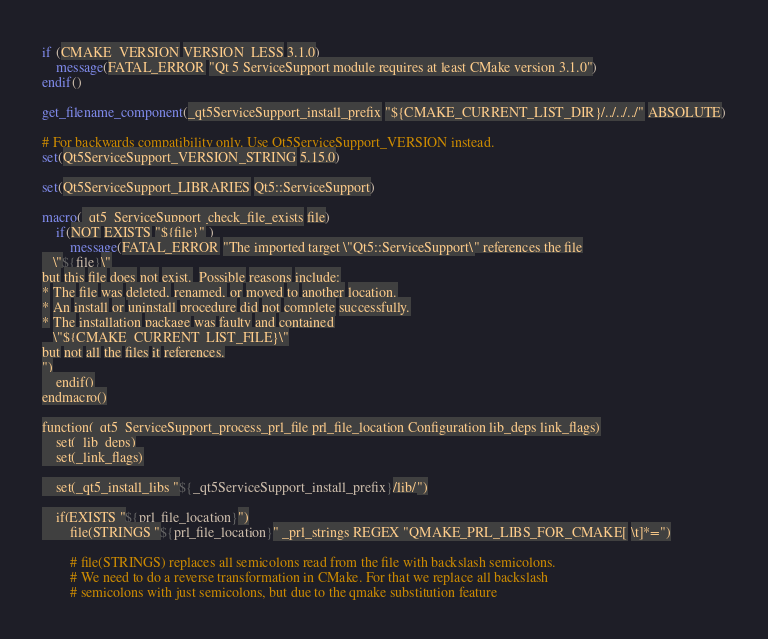Convert code to text. <code><loc_0><loc_0><loc_500><loc_500><_CMake_>if (CMAKE_VERSION VERSION_LESS 3.1.0)
    message(FATAL_ERROR "Qt 5 ServiceSupport module requires at least CMake version 3.1.0")
endif()

get_filename_component(_qt5ServiceSupport_install_prefix "${CMAKE_CURRENT_LIST_DIR}/../../../" ABSOLUTE)

# For backwards compatibility only. Use Qt5ServiceSupport_VERSION instead.
set(Qt5ServiceSupport_VERSION_STRING 5.15.0)

set(Qt5ServiceSupport_LIBRARIES Qt5::ServiceSupport)

macro(_qt5_ServiceSupport_check_file_exists file)
    if(NOT EXISTS "${file}" )
        message(FATAL_ERROR "The imported target \"Qt5::ServiceSupport\" references the file
   \"${file}\"
but this file does not exist.  Possible reasons include:
* The file was deleted, renamed, or moved to another location.
* An install or uninstall procedure did not complete successfully.
* The installation package was faulty and contained
   \"${CMAKE_CURRENT_LIST_FILE}\"
but not all the files it references.
")
    endif()
endmacro()

function(_qt5_ServiceSupport_process_prl_file prl_file_location Configuration lib_deps link_flags)
    set(_lib_deps)
    set(_link_flags)

    set(_qt5_install_libs "${_qt5ServiceSupport_install_prefix}/lib/")

    if(EXISTS "${prl_file_location}")
        file(STRINGS "${prl_file_location}" _prl_strings REGEX "QMAKE_PRL_LIBS_FOR_CMAKE[ \t]*=")

        # file(STRINGS) replaces all semicolons read from the file with backslash semicolons.
        # We need to do a reverse transformation in CMake. For that we replace all backslash
        # semicolons with just semicolons, but due to the qmake substitution feature</code> 